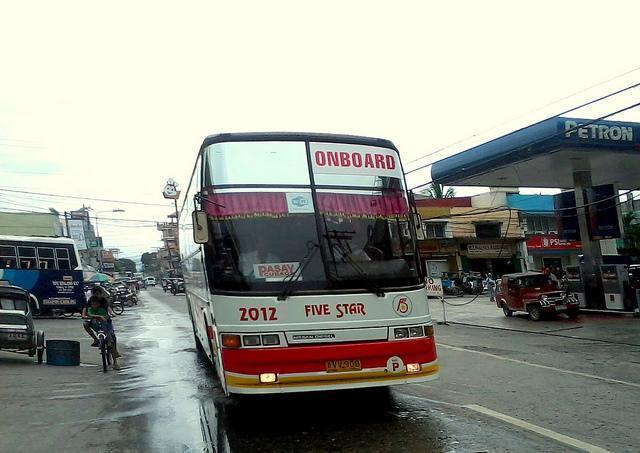Why is the red vehicle on the right stopped at the building?
Select the accurate answer and provide justification: `Answer: choice
Rationale: srationale.`
Options: To race, refueling, broke down, changing tires. Answer: refueling.
Rationale: The red vehicle on the right is stopped to refuel at the gas station. 